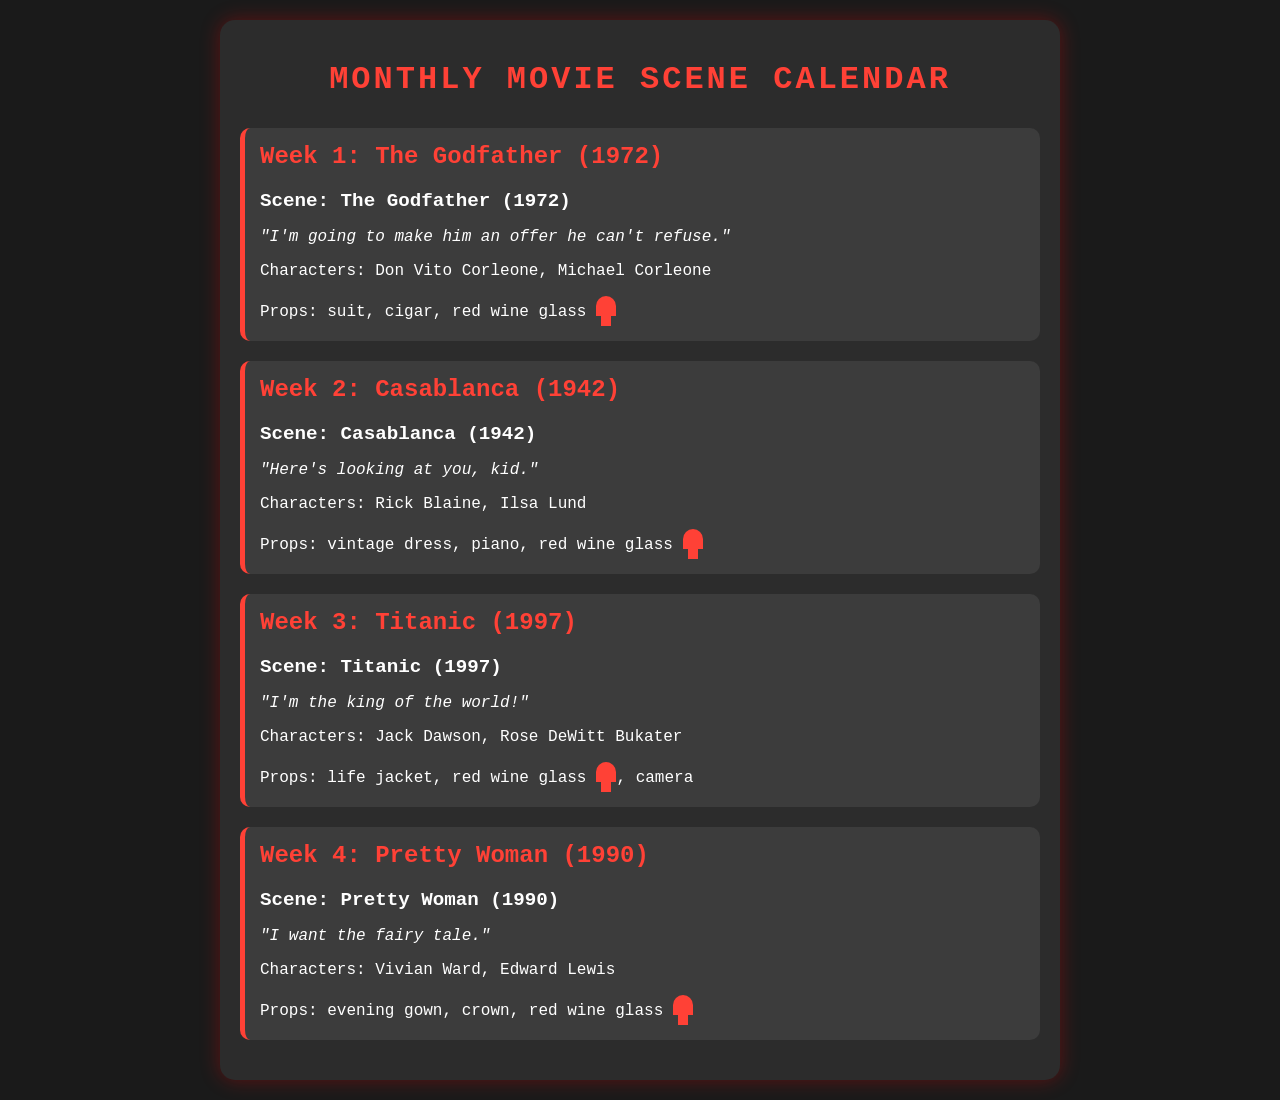What is the title of the movie for Week 1? The title of the movie for Week 1 is mentioned in the section as The Godfather (1972).
Answer: The Godfather (1972) What is the key dialogue from the scene in Week 2? The key dialogue from the scene in Week 2 is listed as "Here's looking at you, kid."
Answer: "Here's looking at you, kid." Who are the characters in the scene from Week 3? The characters for Week 3 are identified as Jack Dawson and Rose DeWitt Bukater.
Answer: Jack Dawson, Rose DeWitt Bukater What is one of the props needed for the scene in Week 4? One of the props needed for the scene in Week 4 is stipulated to be an evening gown.
Answer: evening gown How many weeks are included in the Monthly Movie Scene Calendar? The document lists four weeks, each with a different movie and scene.
Answer: 4 Which movie features the dialogue "I'm the king of the world!"? The movie associated with this dialogue is identified in the document as Titanic (1997).
Answer: Titanic (1997) For which movie do the characters Vivian Ward and Edward Lewis appear? The characters are mentioned in the context of the movie Pretty Woman (1990).
Answer: Pretty Woman (1990) What color wine glass is mentioned throughout the schedule? The color of the wine glass referenced in the props for each scene is red.
Answer: red What scene is scheduled for Week 2? The scene scheduled for Week 2 is provided as Casablanca (1942).
Answer: Casablanca (1942) 